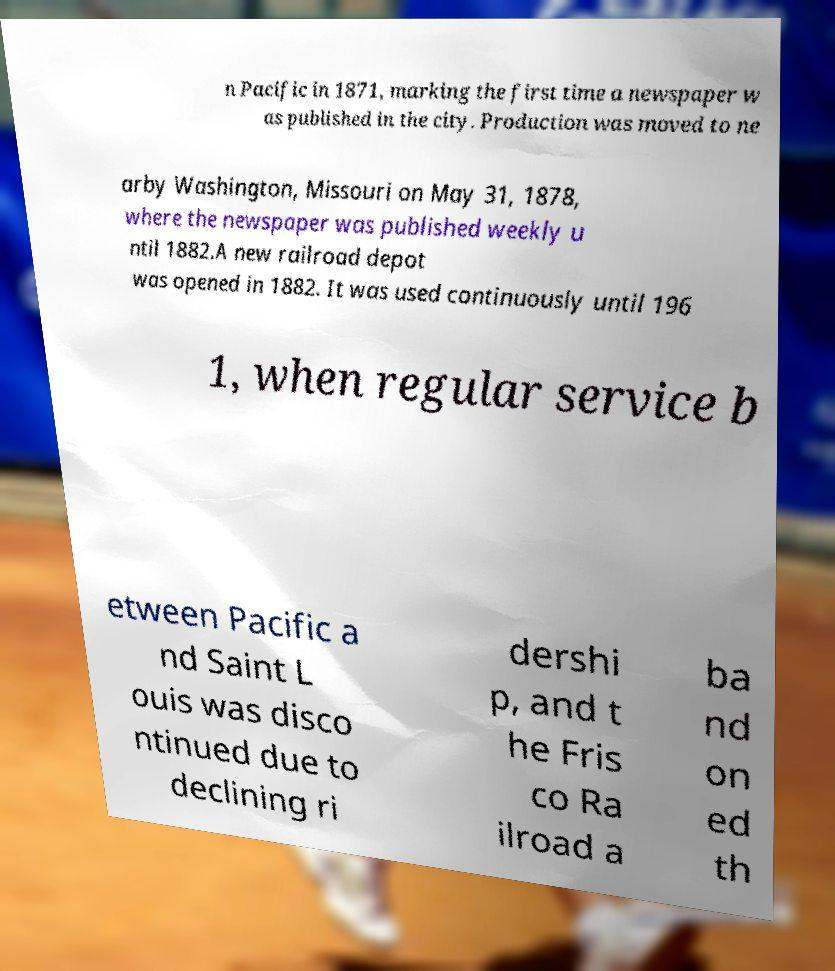I need the written content from this picture converted into text. Can you do that? n Pacific in 1871, marking the first time a newspaper w as published in the city. Production was moved to ne arby Washington, Missouri on May 31, 1878, where the newspaper was published weekly u ntil 1882.A new railroad depot was opened in 1882. It was used continuously until 196 1, when regular service b etween Pacific a nd Saint L ouis was disco ntinued due to declining ri dershi p, and t he Fris co Ra ilroad a ba nd on ed th 